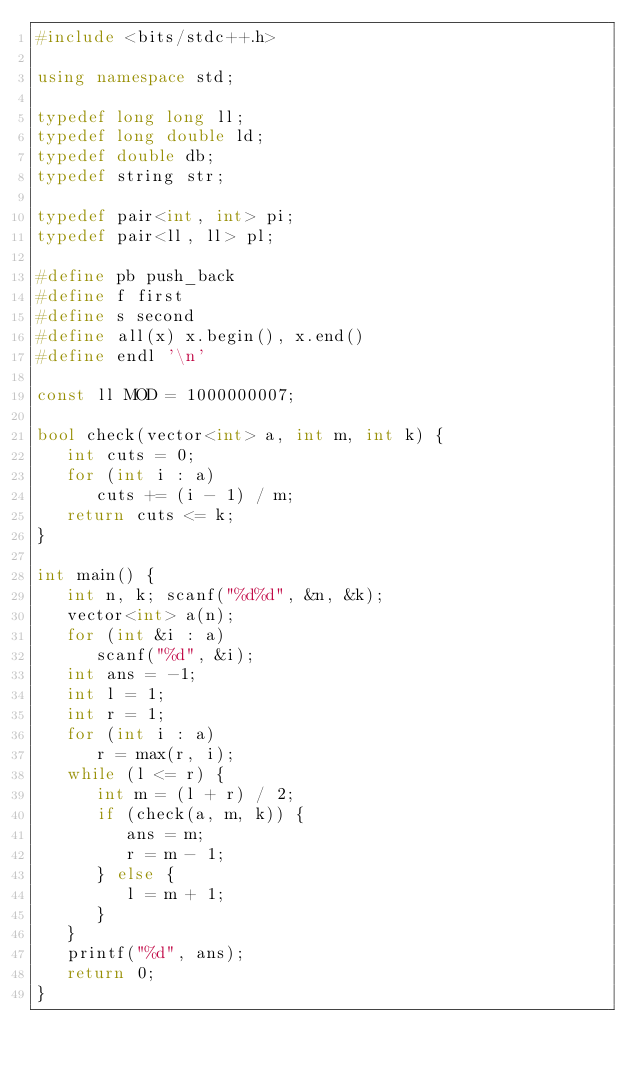<code> <loc_0><loc_0><loc_500><loc_500><_C++_>#include <bits/stdc++.h>

using namespace std;
 
typedef long long ll;
typedef long double ld;
typedef double db; 
typedef string str;
 
typedef pair<int, int> pi;
typedef pair<ll, ll> pl;
 
#define pb push_back
#define f first
#define s second
#define all(x) x.begin(), x.end()
#define endl '\n'
 
const ll MOD = 1000000007;

bool check(vector<int> a, int m, int k) {
   int cuts = 0;
   for (int i : a)
      cuts += (i - 1) / m;
   return cuts <= k;
}

int main() {
   int n, k; scanf("%d%d", &n, &k);
   vector<int> a(n);
   for (int &i : a)
      scanf("%d", &i);
   int ans = -1;
   int l = 1;
   int r = 1;
   for (int i : a)
      r = max(r, i);
   while (l <= r) {
      int m = (l + r) / 2;
      if (check(a, m, k)) {
         ans = m;
         r = m - 1;
      } else {
         l = m + 1;
      }
   }
   printf("%d", ans);
   return 0;
}</code> 